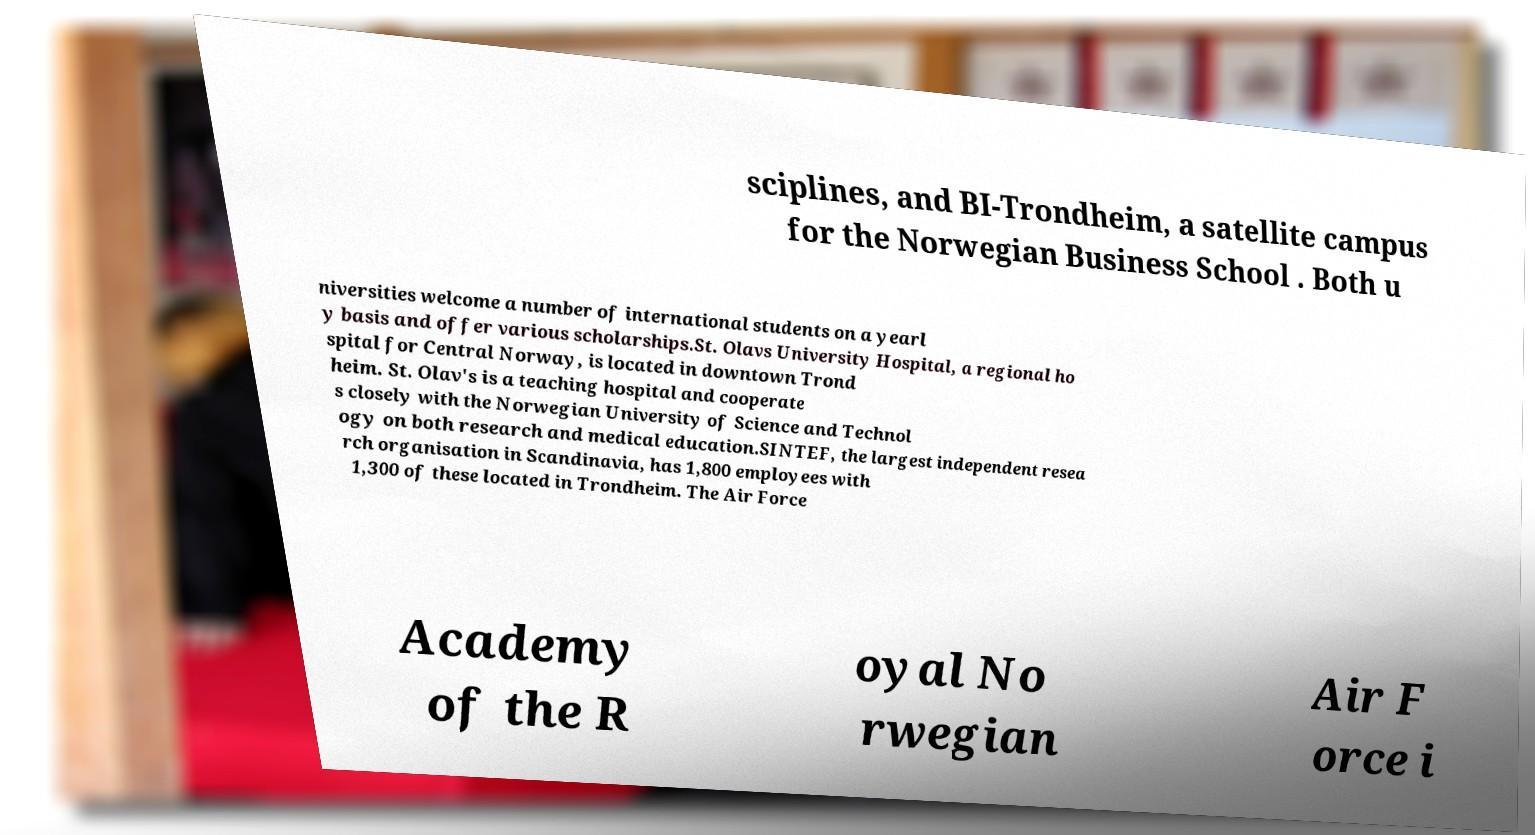Can you accurately transcribe the text from the provided image for me? sciplines, and BI-Trondheim, a satellite campus for the Norwegian Business School . Both u niversities welcome a number of international students on a yearl y basis and offer various scholarships.St. Olavs University Hospital, a regional ho spital for Central Norway, is located in downtown Trond heim. St. Olav's is a teaching hospital and cooperate s closely with the Norwegian University of Science and Technol ogy on both research and medical education.SINTEF, the largest independent resea rch organisation in Scandinavia, has 1,800 employees with 1,300 of these located in Trondheim. The Air Force Academy of the R oyal No rwegian Air F orce i 